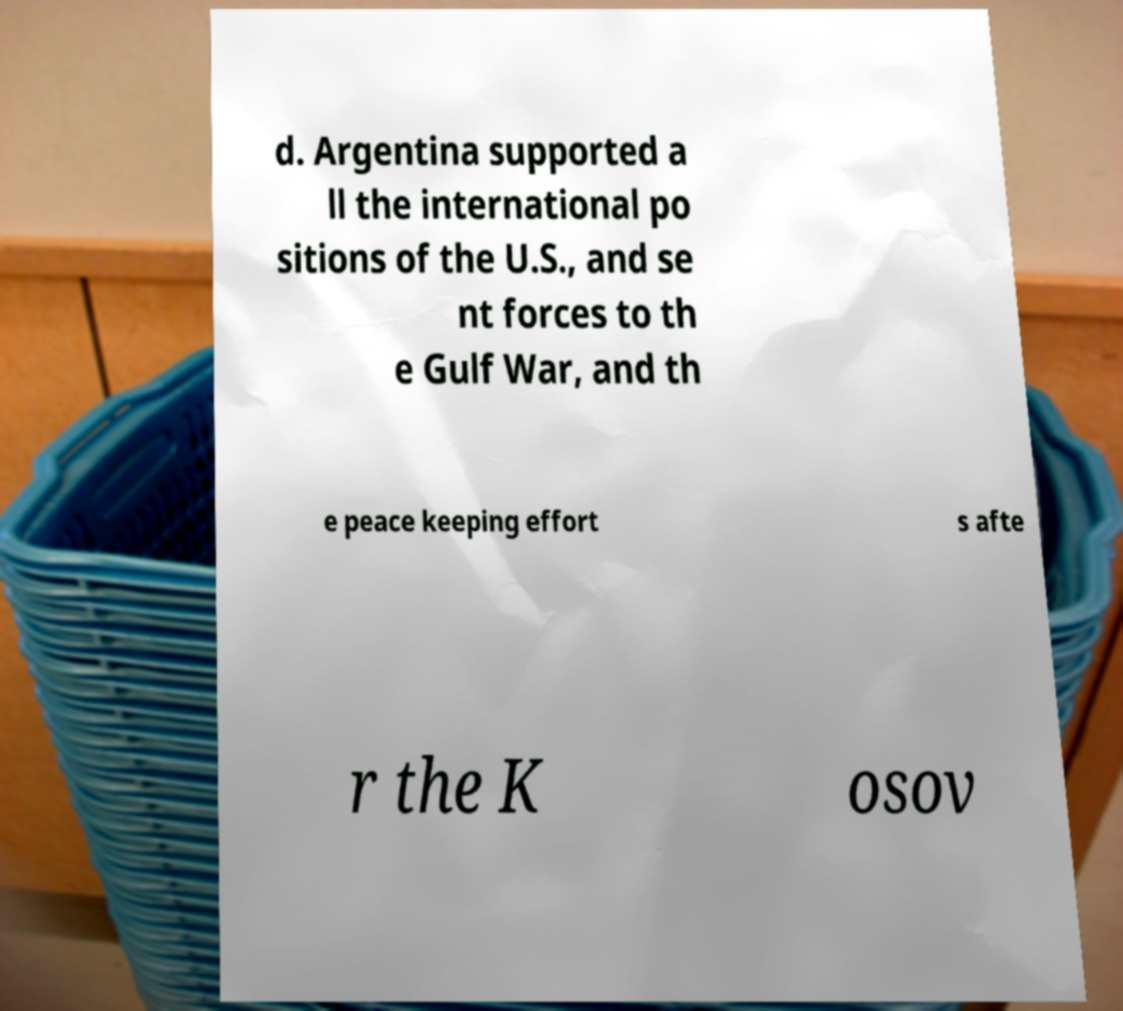Can you accurately transcribe the text from the provided image for me? d. Argentina supported a ll the international po sitions of the U.S., and se nt forces to th e Gulf War, and th e peace keeping effort s afte r the K osov 